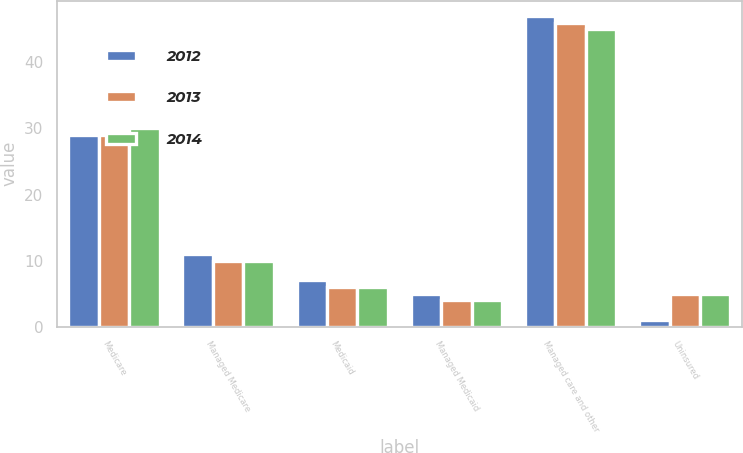<chart> <loc_0><loc_0><loc_500><loc_500><stacked_bar_chart><ecel><fcel>Medicare<fcel>Managed Medicare<fcel>Medicaid<fcel>Managed Medicaid<fcel>Managed care and other<fcel>Uninsured<nl><fcel>2012<fcel>29<fcel>11<fcel>7<fcel>5<fcel>47<fcel>1<nl><fcel>2013<fcel>29<fcel>10<fcel>6<fcel>4<fcel>46<fcel>5<nl><fcel>2014<fcel>30<fcel>10<fcel>6<fcel>4<fcel>45<fcel>5<nl></chart> 